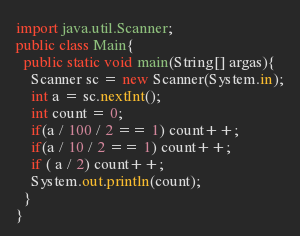<code> <loc_0><loc_0><loc_500><loc_500><_Java_>import java.util.Scanner;
public class Main{
  public static void main(String[] argas){
    Scanner sc = new Scanner(System.in);
    int a = sc.nextInt();
    int count = 0;
    if(a / 100 / 2 == 1) count++;
    if(a / 10 / 2 == 1) count++;
    if ( a / 2) count++;
    System.out.println(count);
  }
}
</code> 